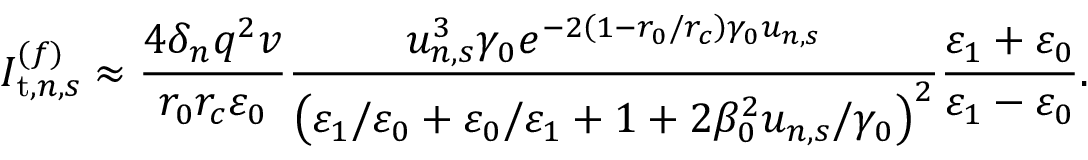<formula> <loc_0><loc_0><loc_500><loc_500>I _ { t , n , s } ^ { ( f ) } \approx \frac { 4 \delta _ { n } q ^ { 2 } v } { r _ { 0 } r _ { c } \varepsilon _ { 0 } } \frac { u _ { n , s } ^ { 3 } \gamma _ { 0 } e ^ { - 2 \left ( 1 - r _ { 0 } / r _ { c } \right ) \gamma _ { 0 } u _ { n , s } } } { \left ( \varepsilon _ { 1 } / \varepsilon _ { 0 } + \varepsilon _ { 0 } / \varepsilon _ { 1 } + 1 + 2 \beta _ { 0 } ^ { 2 } u _ { n , s } / \gamma _ { 0 } \right ) ^ { 2 } } \frac { \varepsilon _ { 1 } + \varepsilon _ { 0 } } { \varepsilon _ { 1 } - \varepsilon _ { 0 } } .</formula> 